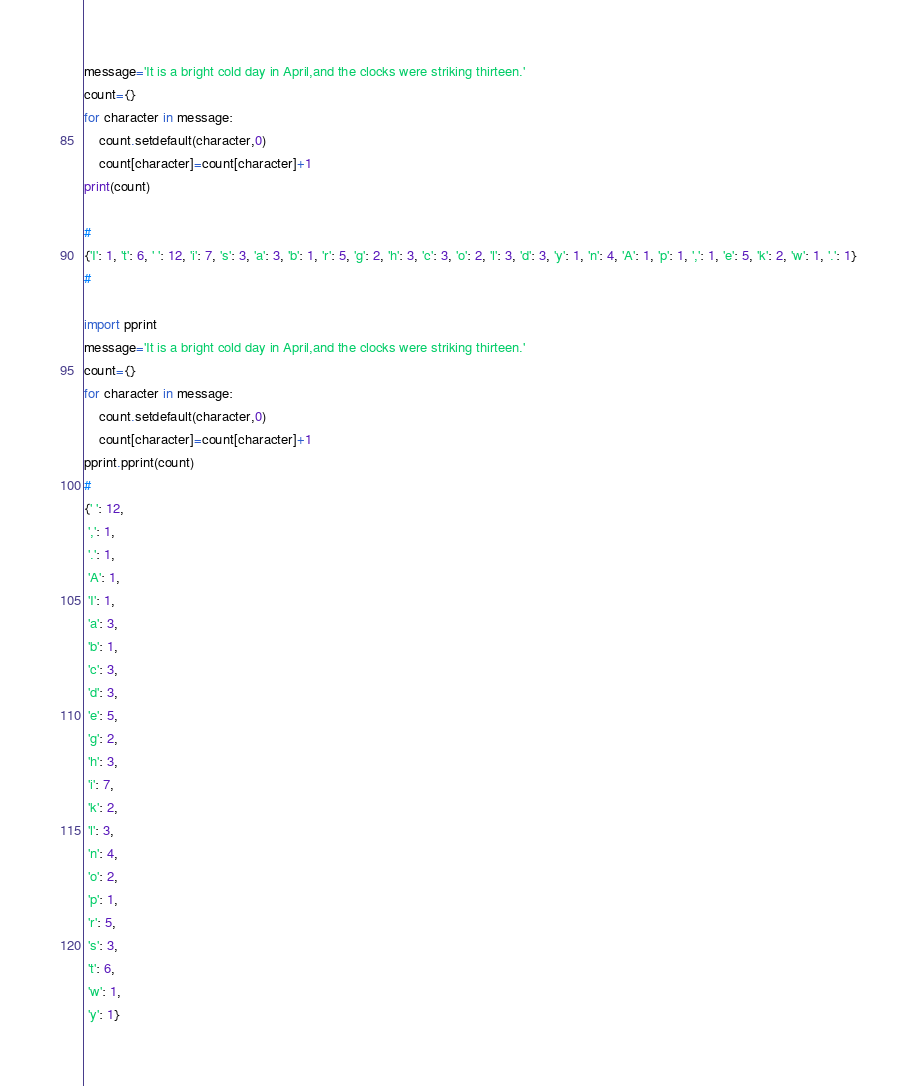<code> <loc_0><loc_0><loc_500><loc_500><_Python_>message='It is a bright cold day in April,and the clocks were striking thirteen.'
count={}
for character in message:
    count.setdefault(character,0)
    count[character]=count[character]+1
print(count)

#
{'I': 1, 't': 6, ' ': 12, 'i': 7, 's': 3, 'a': 3, 'b': 1, 'r': 5, 'g': 2, 'h': 3, 'c': 3, 'o': 2, 'l': 3, 'd': 3, 'y': 1, 'n': 4, 'A': 1, 'p': 1, ',': 1, 'e': 5, 'k': 2, 'w': 1, '.': 1}
#

import pprint
message='It is a bright cold day in April,and the clocks were striking thirteen.'
count={}
for character in message:
    count.setdefault(character,0)
    count[character]=count[character]+1
pprint.pprint(count)
#
{' ': 12,
 ',': 1,
 '.': 1,
 'A': 1,
 'I': 1,
 'a': 3,
 'b': 1,
 'c': 3,
 'd': 3,
 'e': 5,
 'g': 2,
 'h': 3,
 'i': 7,
 'k': 2,
 'l': 3,
 'n': 4,
 'o': 2,
 'p': 1,
 'r': 5,
 's': 3,
 't': 6,
 'w': 1,
 'y': 1}
</code> 